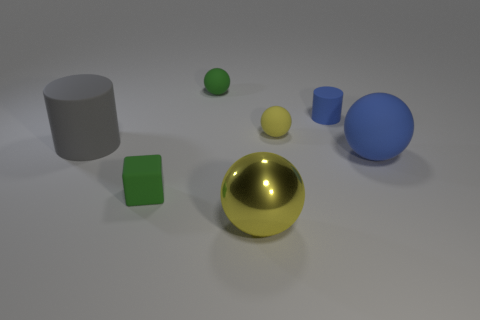What is the shape of the yellow object behind the large yellow thing?
Keep it short and to the point. Sphere. There is a object that is the same color as the small rubber cylinder; what is its size?
Your answer should be compact. Large. What is the large yellow ball made of?
Provide a short and direct response. Metal. There is a rubber cylinder that is the same size as the yellow metal object; what is its color?
Offer a very short reply. Gray. There is a matte object that is the same color as the block; what is its shape?
Keep it short and to the point. Sphere. Is the shape of the gray object the same as the tiny yellow object?
Provide a short and direct response. No. There is a big object that is left of the blue matte cylinder and to the right of the small green cube; what material is it?
Make the answer very short. Metal. How big is the yellow matte object?
Make the answer very short. Small. The large metal object that is the same shape as the tiny yellow rubber thing is what color?
Your answer should be compact. Yellow. Is there anything else of the same color as the small matte block?
Offer a terse response. Yes. 